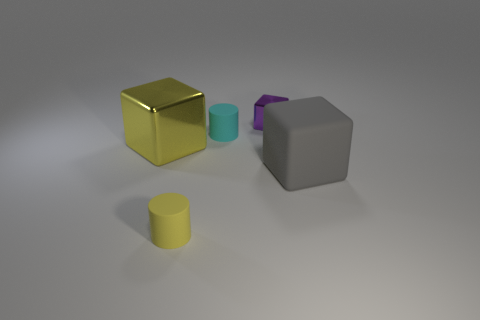Subtract all gray rubber blocks. How many blocks are left? 2 Add 5 large metal things. How many objects exist? 10 Subtract all brown blocks. Subtract all red cylinders. How many blocks are left? 3 Subtract all blocks. How many objects are left? 2 Add 4 large gray cubes. How many large gray cubes are left? 5 Add 3 yellow cylinders. How many yellow cylinders exist? 4 Subtract 0 blue balls. How many objects are left? 5 Subtract all big cyan things. Subtract all large yellow cubes. How many objects are left? 4 